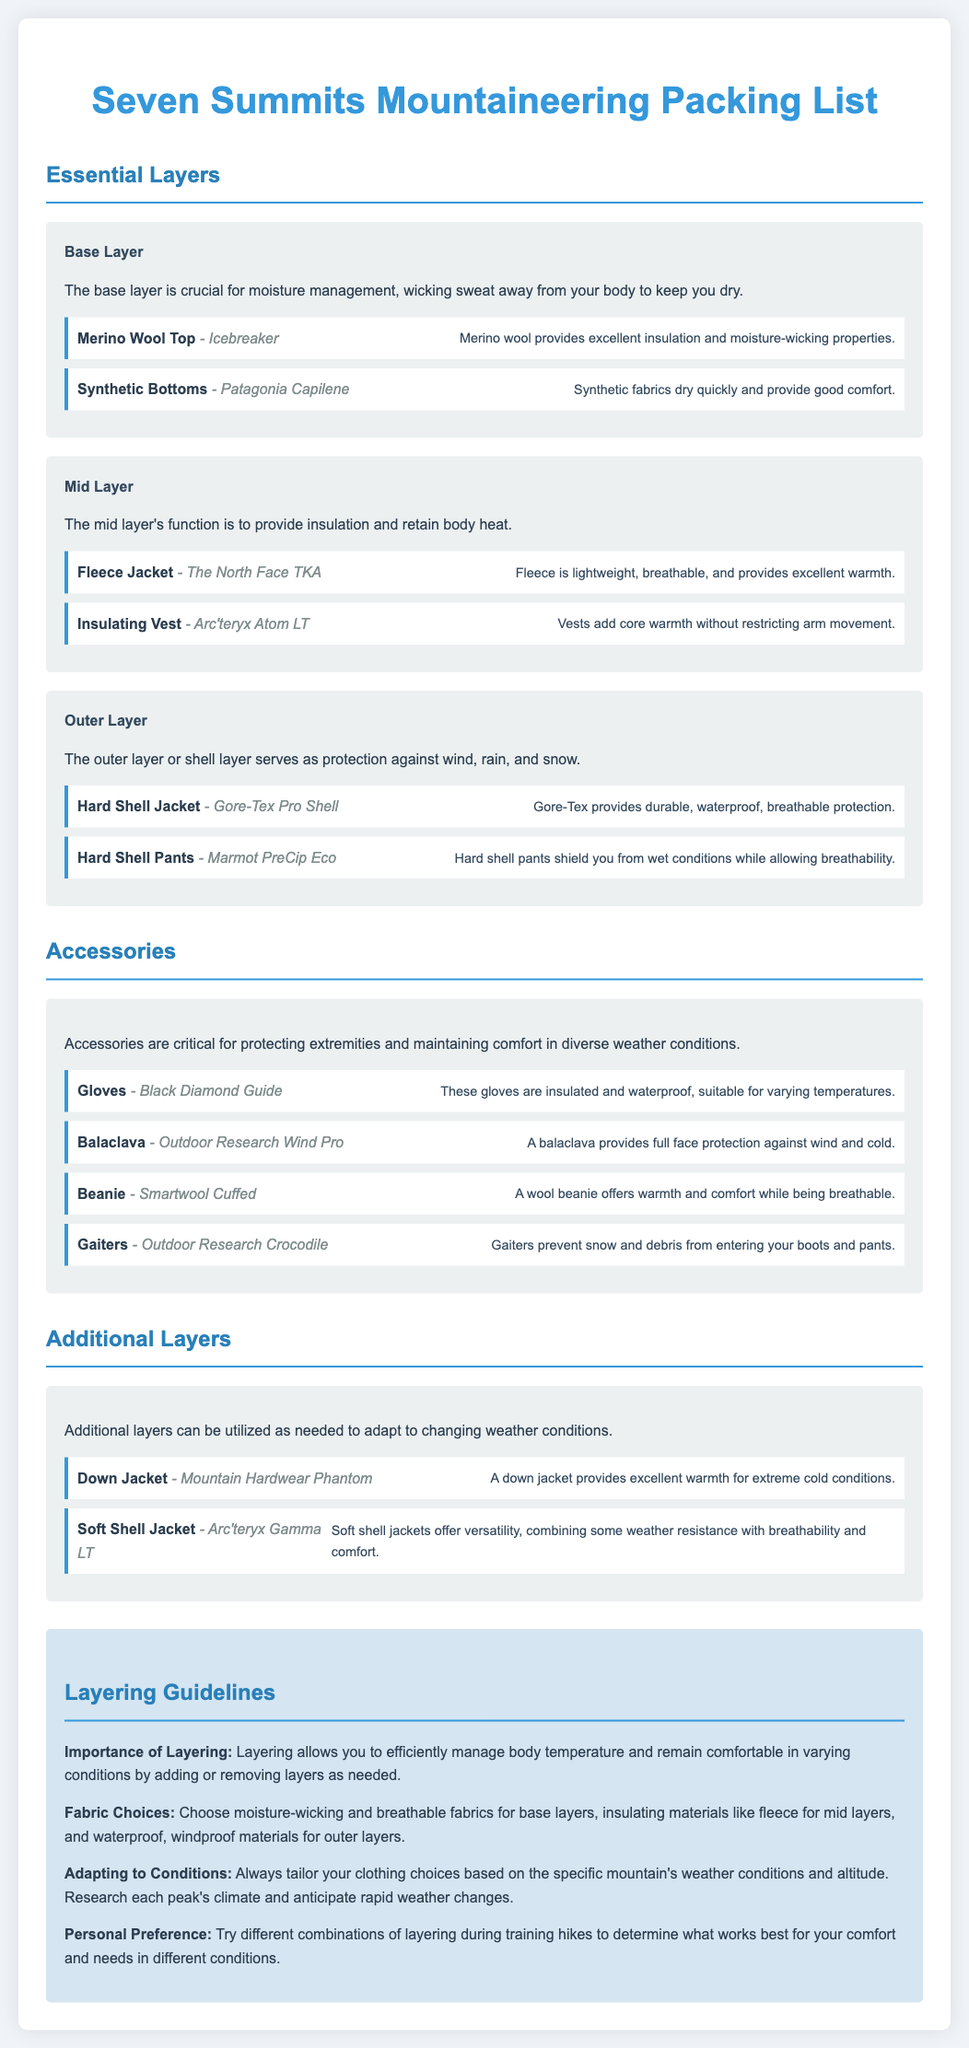what is the first layer in the packing list? The first layer mentioned in the packing list is the Base Layer, which is crucial for moisture management.
Answer: Base Layer which brand is listed for the Merino Wool Top? The document specifies Icebreaker as the brand for the Merino Wool Top in the base layer section.
Answer: Icebreaker what type of jacket is recommended for extreme cold conditions? The packing list suggests a Down Jacket for excellent warmth in extreme cold conditions.
Answer: Down Jacket what is the main purpose of the outer layer? The outer layer's main purpose is to serve as protection against wind, rain, and snow.
Answer: Protection how many items are listed under Accessories? There are four items listed under the Accessories section of the packing list.
Answer: Four what fabric is recommended for mid layers? The document advises using insulating materials like fleece for mid layers.
Answer: Fleece why is layering important according to the guidelines? The guidelines state that layering allows efficient management of body temperature and comfort in varying conditions.
Answer: Efficient management which two jackets are mentioned in the Additional Layers section? The Additional Layers section mentions a Down Jacket and a Soft Shell Jacket.
Answer: Down Jacket, Soft Shell Jacket 